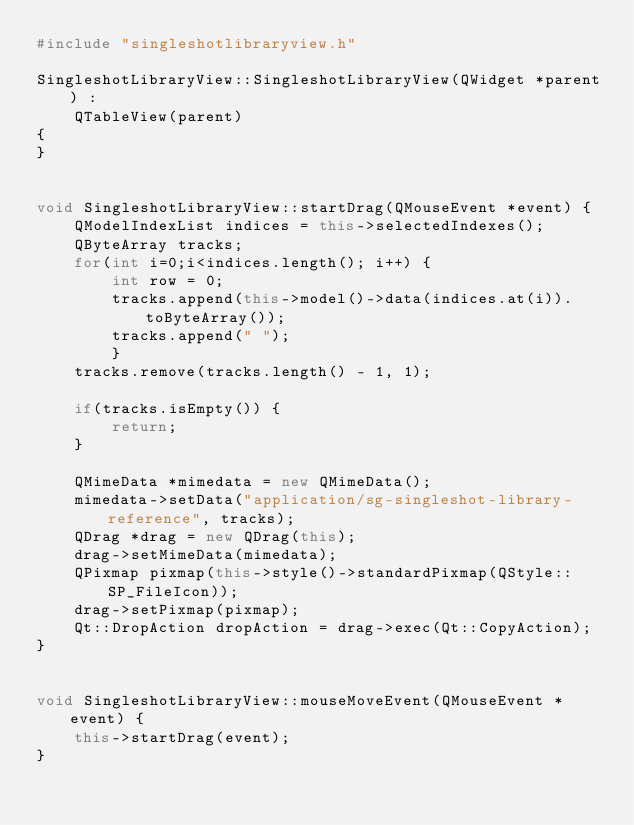Convert code to text. <code><loc_0><loc_0><loc_500><loc_500><_C++_>#include "singleshotlibraryview.h"

SingleshotLibraryView::SingleshotLibraryView(QWidget *parent) :
    QTableView(parent)
{
}


void SingleshotLibraryView::startDrag(QMouseEvent *event) {
    QModelIndexList indices = this->selectedIndexes();
    QByteArray tracks;
    for(int i=0;i<indices.length(); i++) {
        int row = 0;
        tracks.append(this->model()->data(indices.at(i)).toByteArray());
        tracks.append(" ");
        }
    tracks.remove(tracks.length() - 1, 1);

    if(tracks.isEmpty()) {
        return;
    }

    QMimeData *mimedata = new QMimeData();
    mimedata->setData("application/sg-singleshot-library-reference", tracks);
    QDrag *drag = new QDrag(this);
    drag->setMimeData(mimedata);
    QPixmap pixmap(this->style()->standardPixmap(QStyle::SP_FileIcon));
    drag->setPixmap(pixmap);
    Qt::DropAction dropAction = drag->exec(Qt::CopyAction);
}


void SingleshotLibraryView::mouseMoveEvent(QMouseEvent *event) {
    this->startDrag(event);
}
</code> 